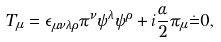Convert formula to latex. <formula><loc_0><loc_0><loc_500><loc_500>T _ { \mu } = \epsilon _ { \mu \nu \lambda \rho } \pi ^ { \nu } \psi ^ { \lambda } \psi ^ { \rho } + i \frac { \alpha } { 2 } \pi _ { \mu } \dot { = } 0 ,</formula> 